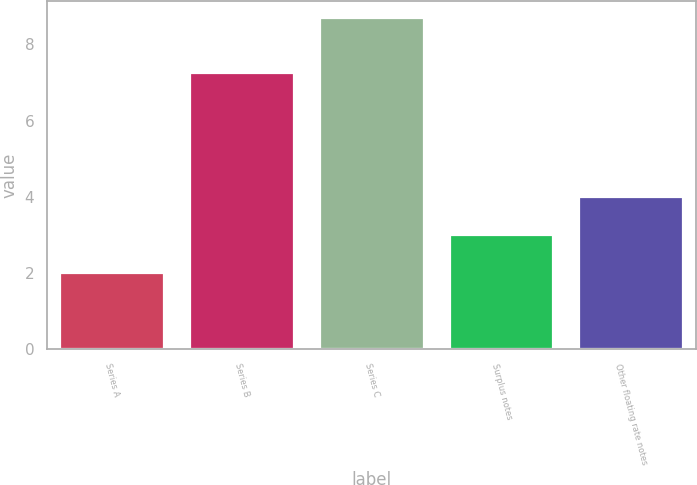<chart> <loc_0><loc_0><loc_500><loc_500><bar_chart><fcel>Series A<fcel>Series B<fcel>Series C<fcel>Surplus notes<fcel>Other floating rate notes<nl><fcel>2<fcel>7.25<fcel>8.7<fcel>3<fcel>4<nl></chart> 